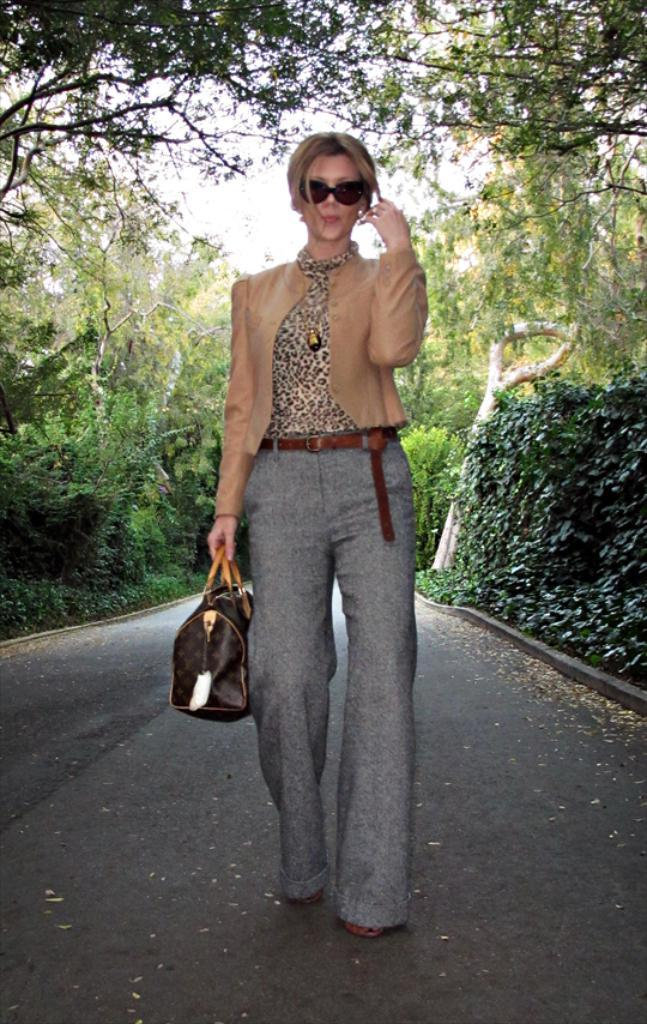Who is present in the image? There is a woman in the image. What is the woman holding? The woman is holding a bag. What is the woman doing in the image? The woman is walking on the road. What can be seen behind the woman? There are trees and plants behind the woman. What word is written on the country visible in the image? There is no country visible in the image, and no word is written on it. 